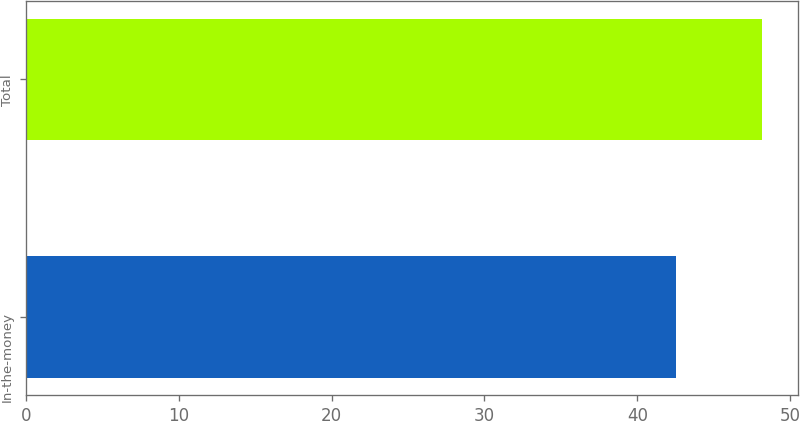<chart> <loc_0><loc_0><loc_500><loc_500><bar_chart><fcel>In-the-money<fcel>Total<nl><fcel>42.49<fcel>48.12<nl></chart> 